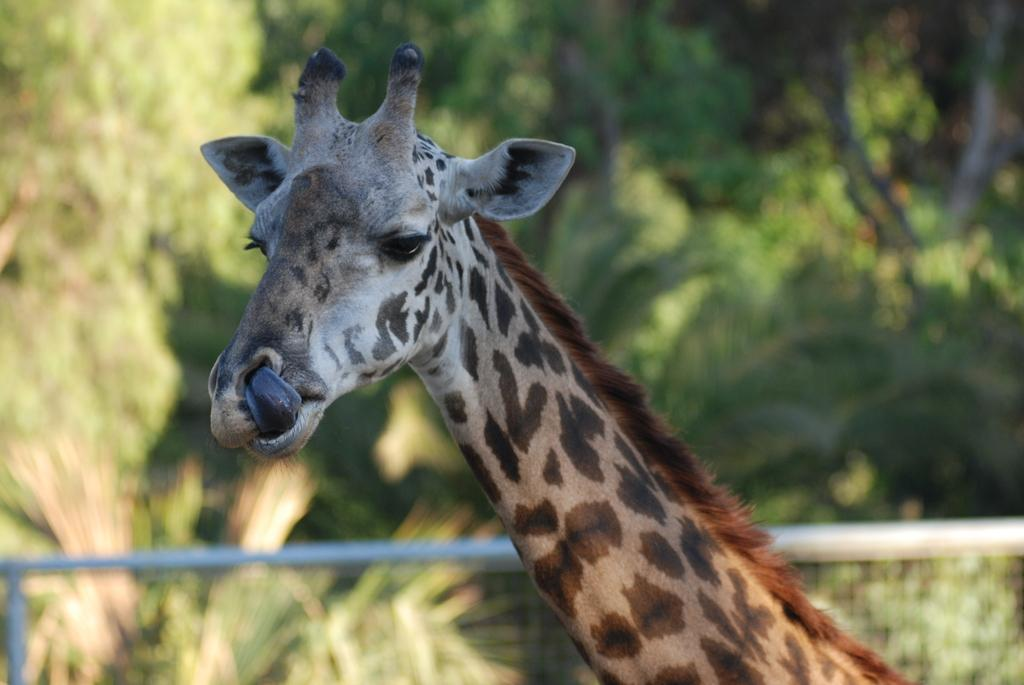What animal is in the center of the image? There is a giraffe in the center of the image. What is located at the bottom of the image? There is a fence at the bottom of the image. What can be seen in the background of the image? There are trees in the background of the image. What type of bun is being used to hold the giraffe's hair in the image? There is no bun present in the image, as giraffes do not have hair that requires holding. 